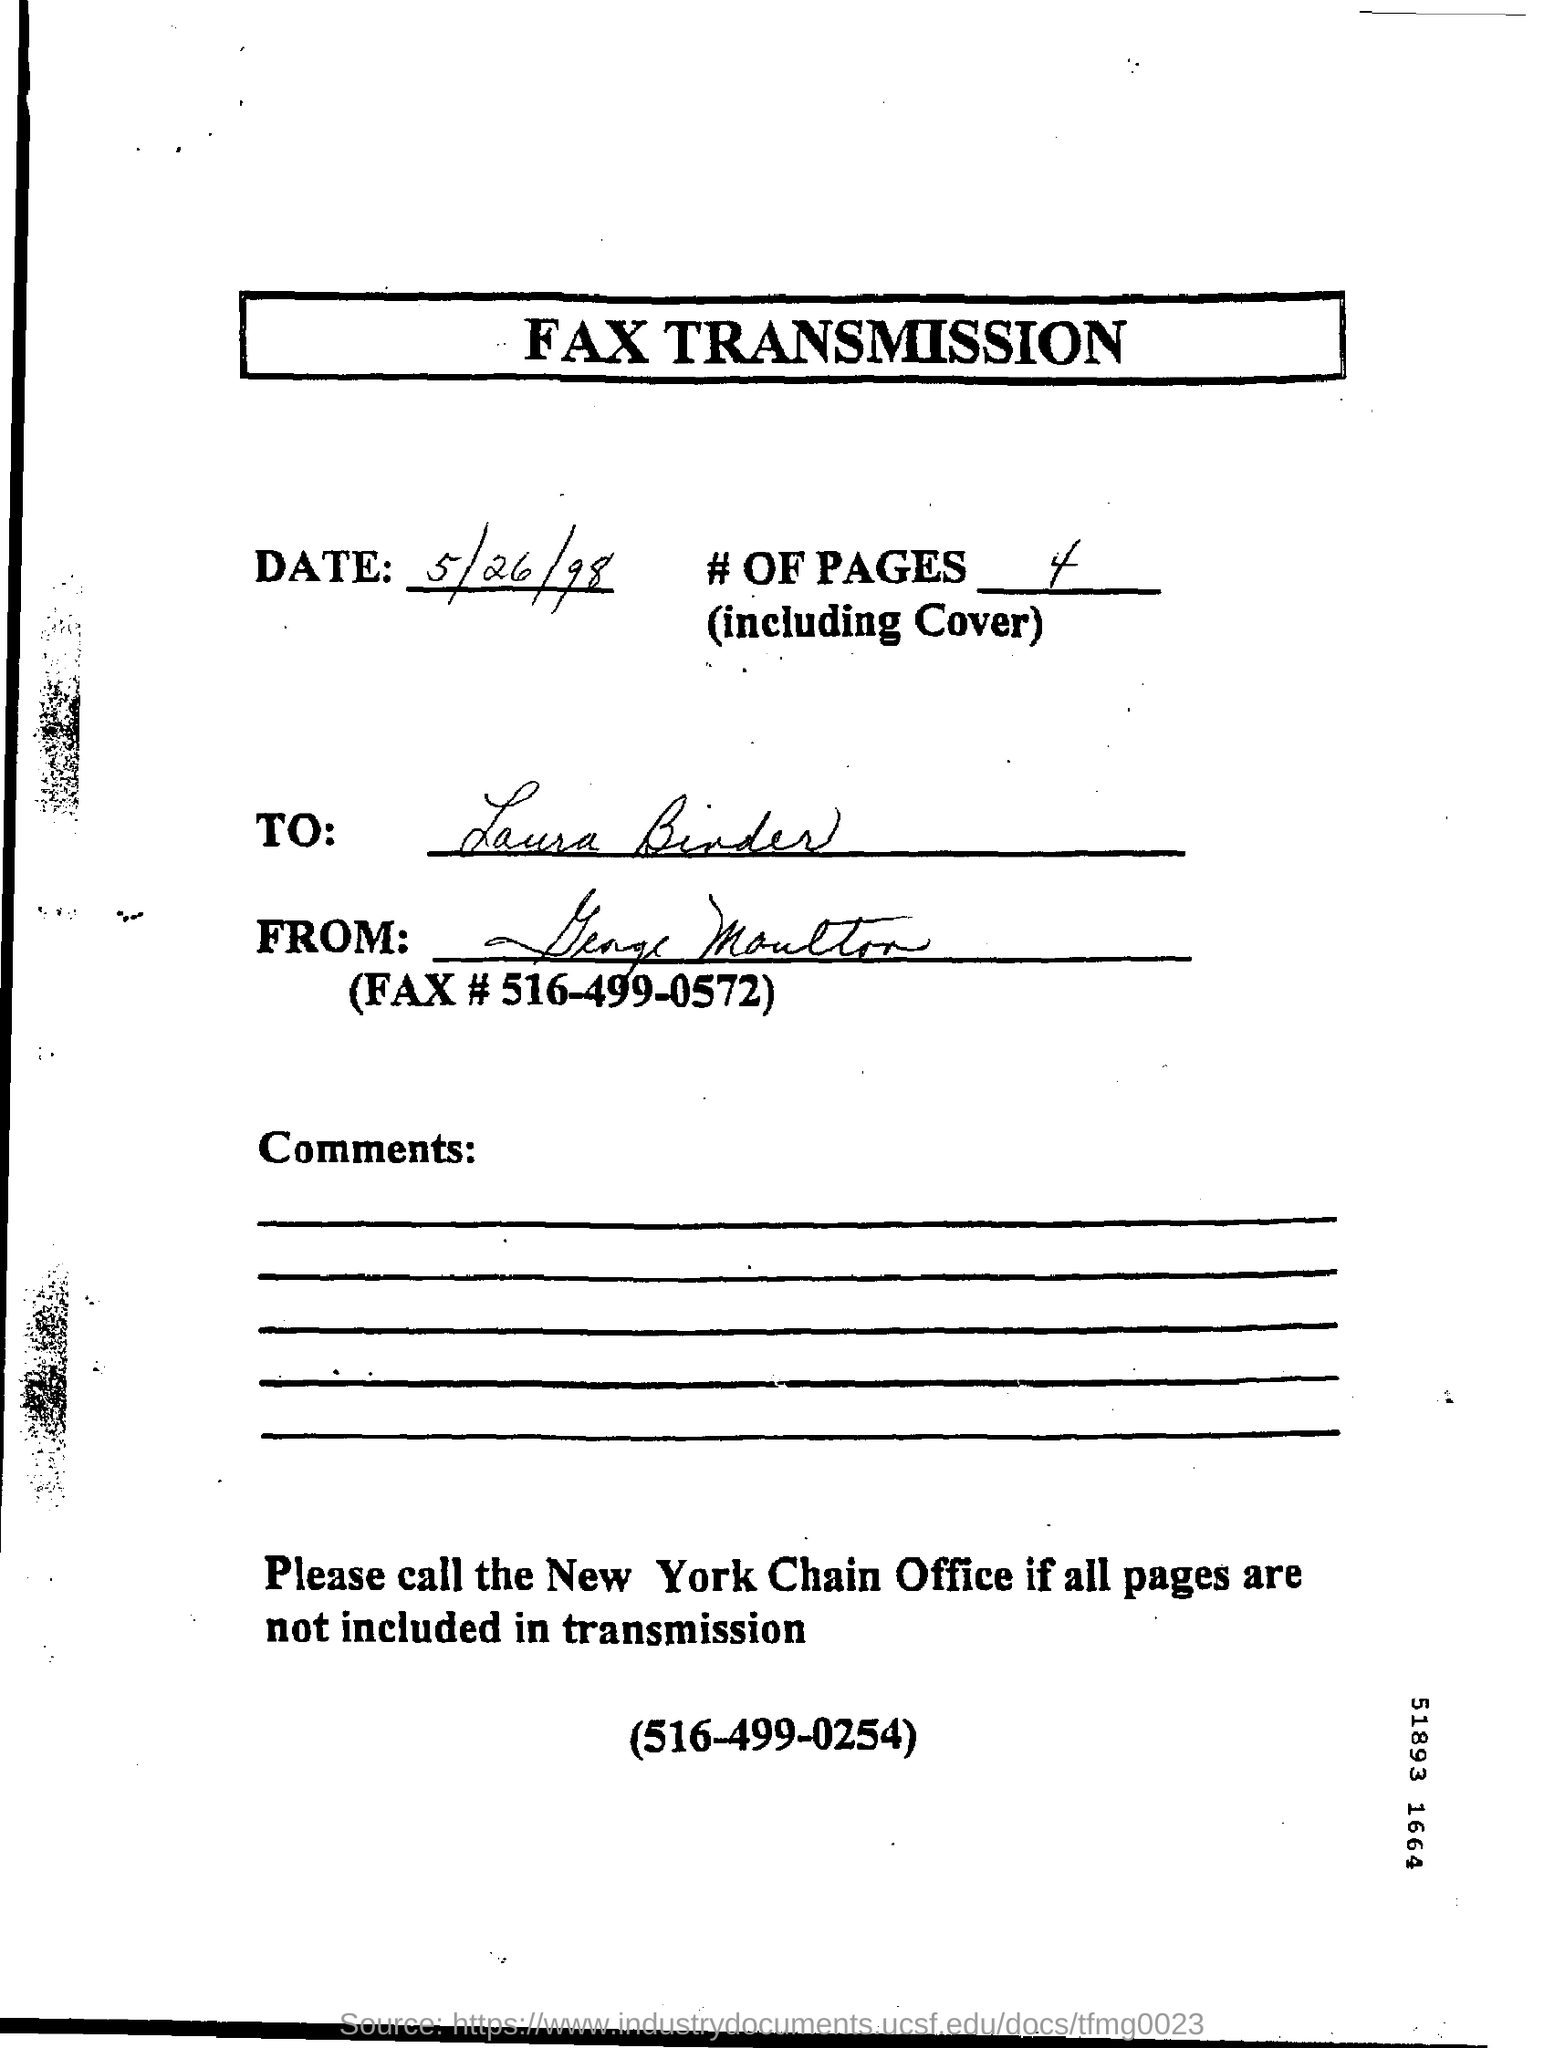Highlight a few significant elements in this photo. The telephone number "516-499-0572" is a fax number. The heading of the page is "What is fax transmission? There are four pages, including the cover, in total. The fax transmission occurred on May 26, 1998. 